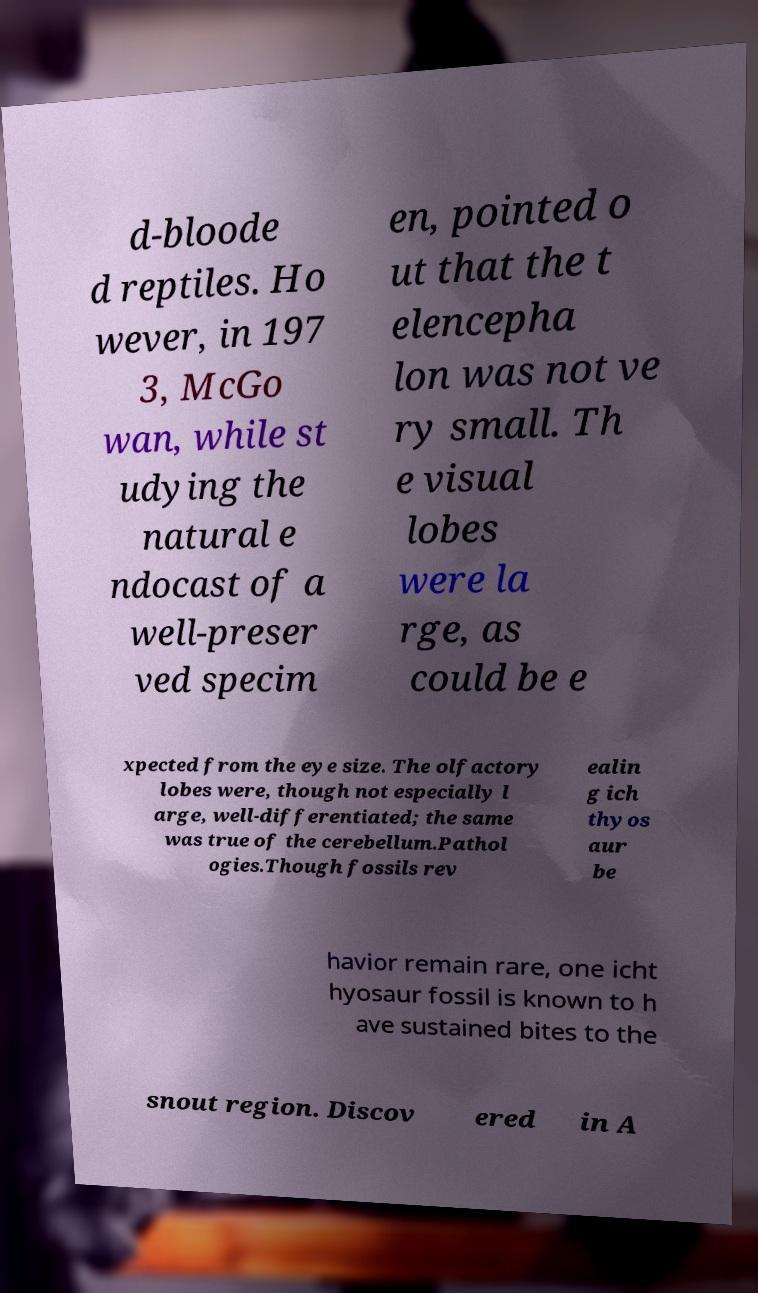For documentation purposes, I need the text within this image transcribed. Could you provide that? d-bloode d reptiles. Ho wever, in 197 3, McGo wan, while st udying the natural e ndocast of a well-preser ved specim en, pointed o ut that the t elencepha lon was not ve ry small. Th e visual lobes were la rge, as could be e xpected from the eye size. The olfactory lobes were, though not especially l arge, well-differentiated; the same was true of the cerebellum.Pathol ogies.Though fossils rev ealin g ich thyos aur be havior remain rare, one icht hyosaur fossil is known to h ave sustained bites to the snout region. Discov ered in A 